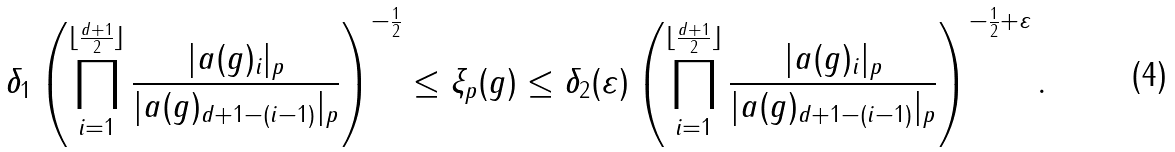Convert formula to latex. <formula><loc_0><loc_0><loc_500><loc_500>\delta _ { 1 } \left ( \prod _ { i = 1 } ^ { \lfloor \frac { d + 1 } { 2 } \rfloor } \frac { | a ( g ) _ { i } | _ { p } } { | a ( g ) _ { d + 1 - ( i - 1 ) } | _ { p } } \right ) ^ { - \frac { 1 } { 2 } } \leq \xi _ { p } ( g ) \leq \delta _ { 2 } ( \varepsilon ) \left ( \prod _ { i = 1 } ^ { \lfloor \frac { d + 1 } { 2 } \rfloor } \frac { | a ( g ) _ { i } | _ { p } } { | a ( g ) _ { d + 1 - ( i - 1 ) } | _ { p } } \right ) ^ { - \frac { 1 } { 2 } + \varepsilon } .</formula> 